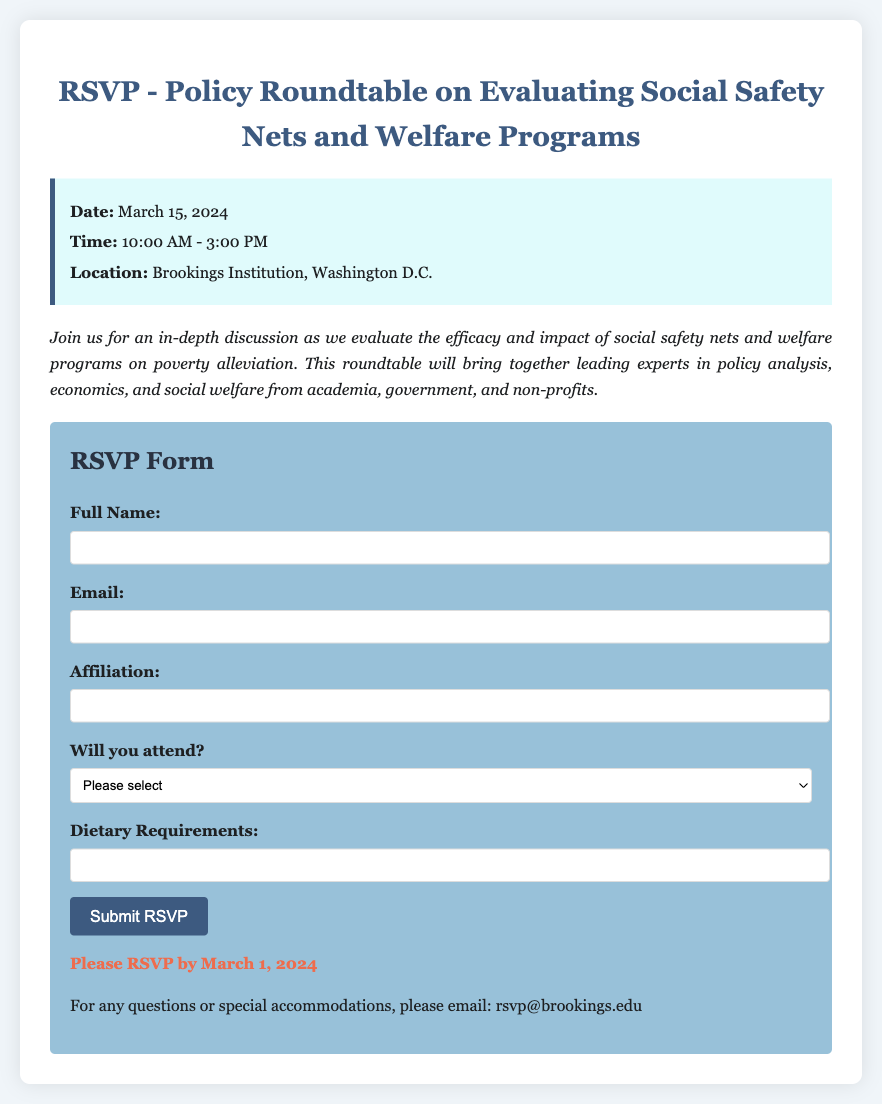what is the date of the event? The date is explicitly stated in the event details section of the document.
Answer: March 15, 2024 what time does the event start? The starting time is mentioned in the event details section.
Answer: 10:00 AM where is the event being held? The location is provided in the event details section of the document.
Answer: Brookings Institution, Washington D.C what is the primary focus of the roundtable discussion? The description section outlines the main topic of the discussion.
Answer: Efficacy and impact of social safety nets and welfare programs what is the deadline for RSVPs? The deadline is clearly noted towards the end of the RSVP form.
Answer: March 1, 2024 what should attendees do if they have questions? The document specifies how to reach out for questions.
Answer: Email rsvp@brookings.edu who is invited to the roundtable? The description section mentions the intended audience for the event.
Answer: Leading experts in policy analysis, economics, and social welfare what dietary requirements can attendees specify? The RSVP form includes a section for dietary needs.
Answer: Dietary Requirements what option is available if someone cannot attend? The RSVP form offers a selection for attendance.
Answer: No, I cannot attend 